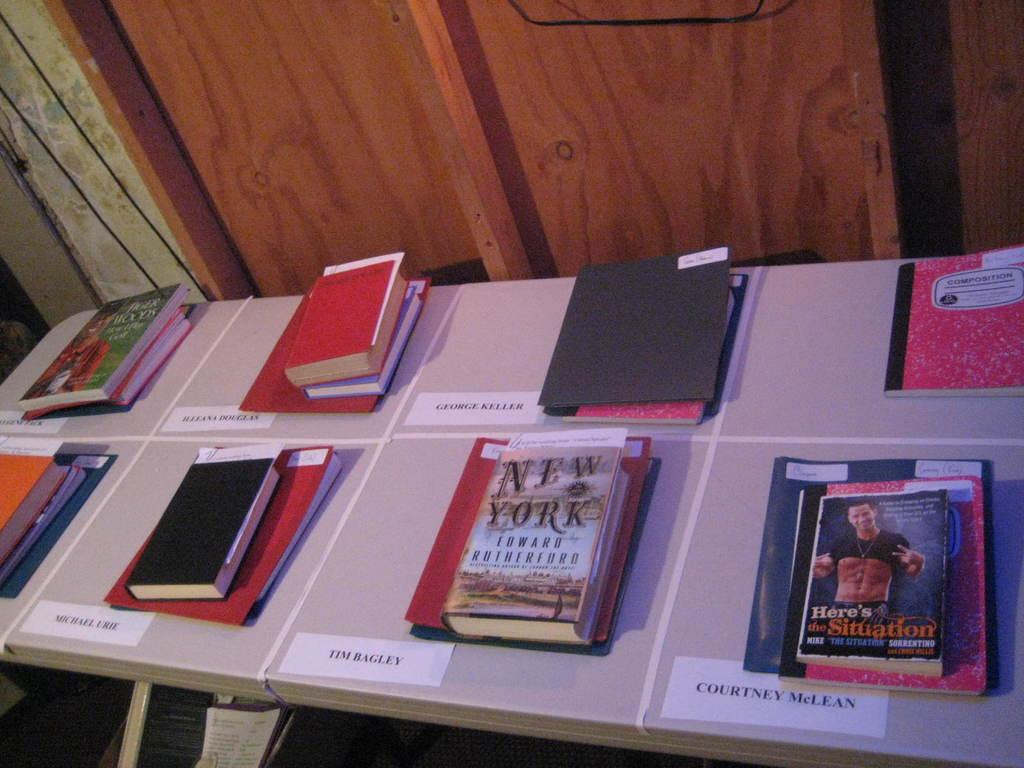Provide a one-sentence caption for the provided image. Small piles of books are arranged on a table with people's names by them, one of the books is about New York. 